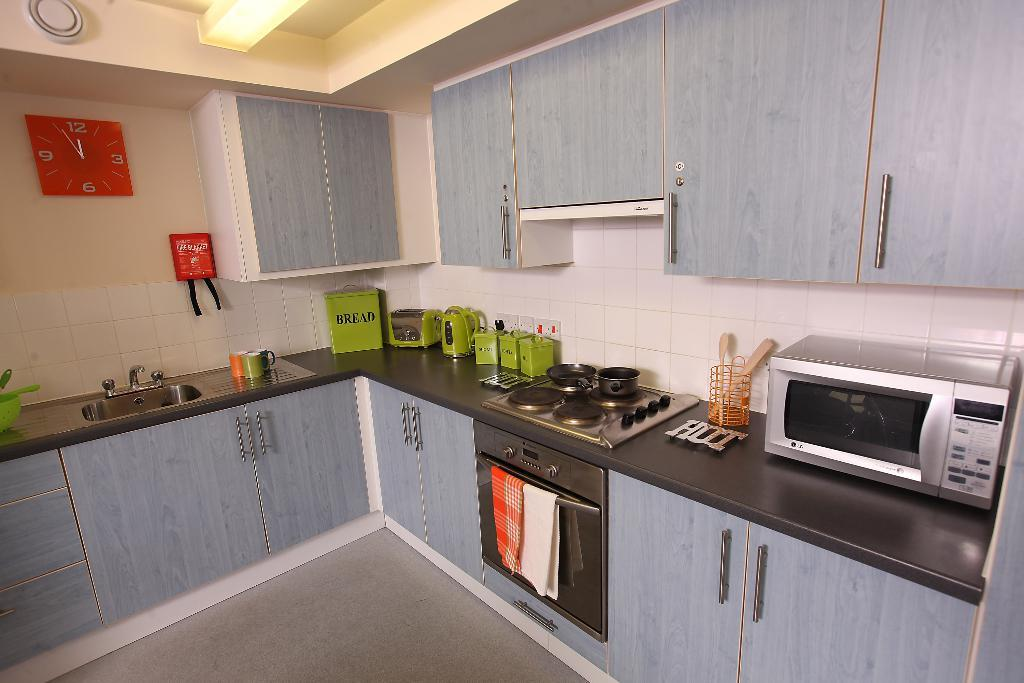Provide a one-sentence caption for the provided image. A kitchen with a silver microwave and a green box that says bread. 